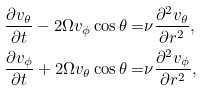<formula> <loc_0><loc_0><loc_500><loc_500>\frac { \partial v _ { \theta } } { \partial t } - 2 \Omega v _ { \phi } \cos \theta = & \nu \frac { \partial ^ { 2 } v _ { \theta } } { \partial r ^ { 2 } } , \\ \frac { \partial v _ { \phi } } { \partial t } + 2 \Omega v _ { \theta } \cos \theta = & \nu \frac { \partial ^ { 2 } v _ { \phi } } { \partial r ^ { 2 } } ,</formula> 